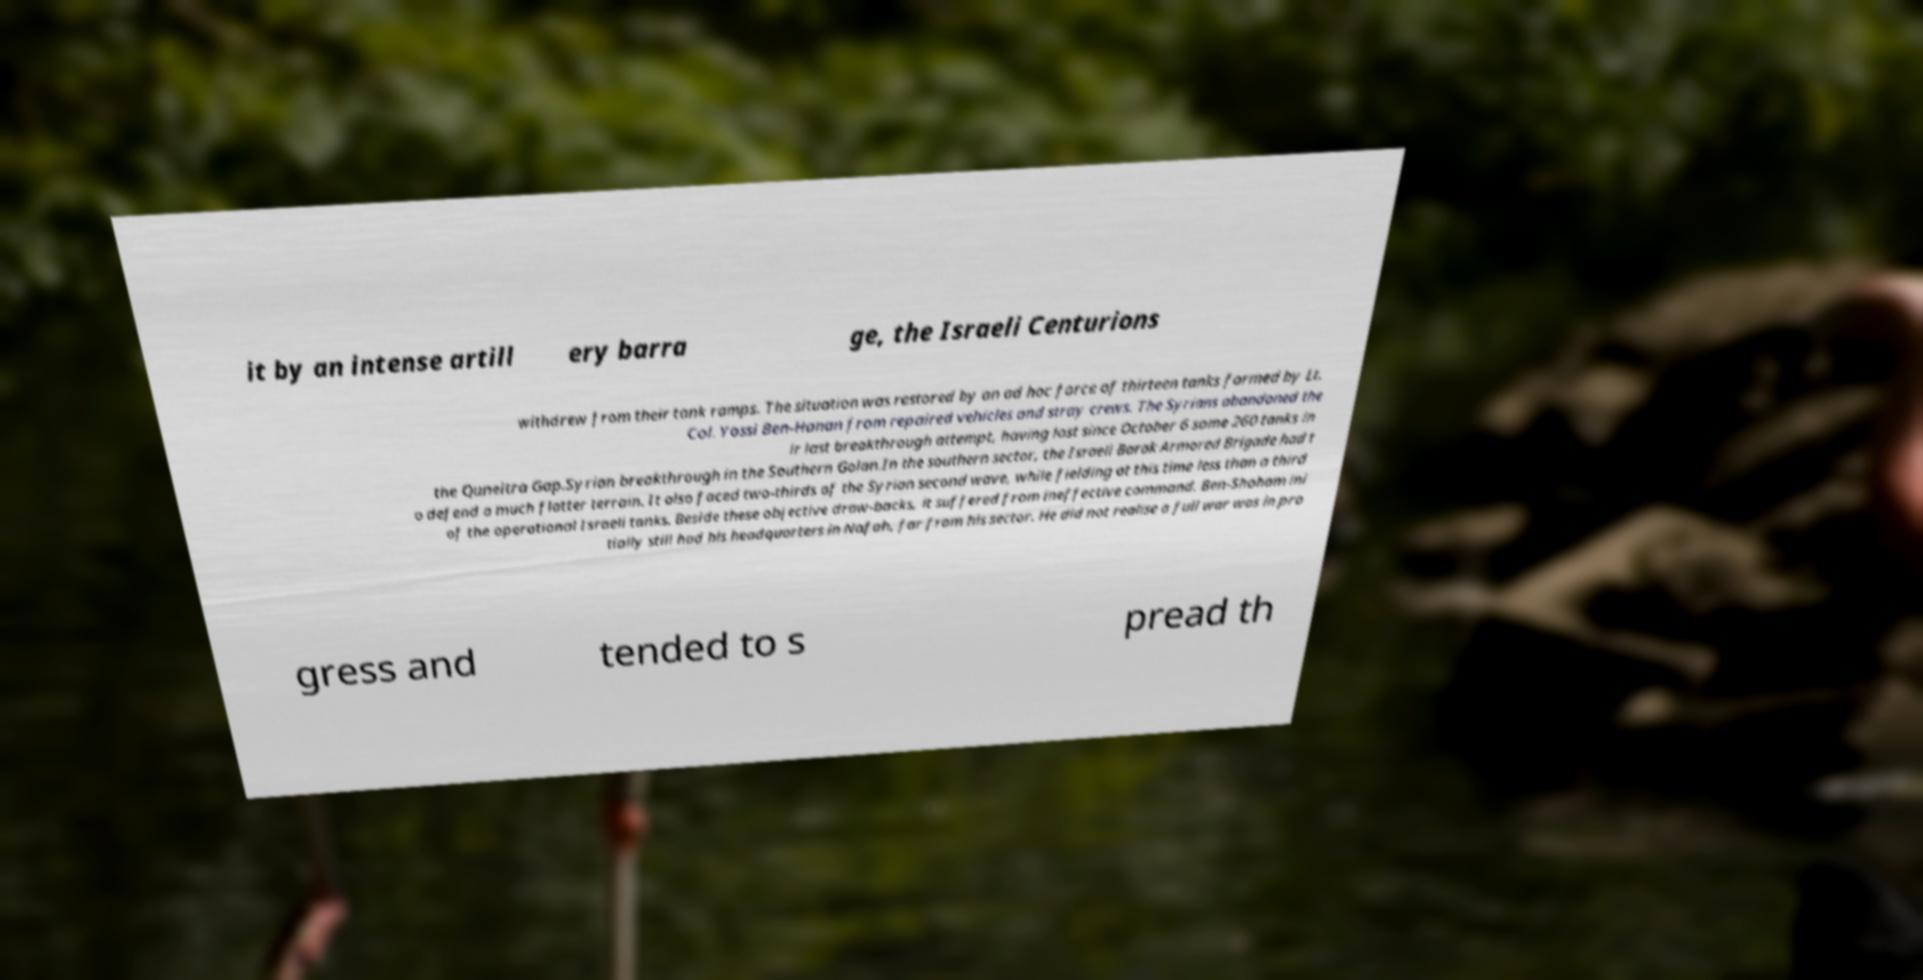Please identify and transcribe the text found in this image. it by an intense artill ery barra ge, the Israeli Centurions withdrew from their tank ramps. The situation was restored by an ad hoc force of thirteen tanks formed by Lt. Col. Yossi Ben-Hanan from repaired vehicles and stray crews. The Syrians abandoned the ir last breakthrough attempt, having lost since October 6 some 260 tanks in the Quneitra Gap.Syrian breakthrough in the Southern Golan.In the southern sector, the Israeli Barak Armored Brigade had t o defend a much flatter terrain. It also faced two-thirds of the Syrian second wave, while fielding at this time less than a third of the operational Israeli tanks. Beside these objective draw-backs, it suffered from ineffective command. Ben-Shoham ini tially still had his headquarters in Nafah, far from his sector. He did not realise a full war was in pro gress and tended to s pread th 